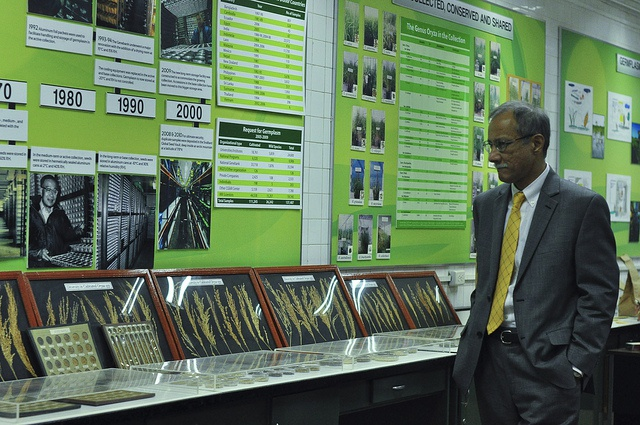Describe the objects in this image and their specific colors. I can see people in lightgreen, black, gray, darkgreen, and darkblue tones, people in lightgreen, black, gray, and darkgray tones, and tie in lightgreen and olive tones in this image. 